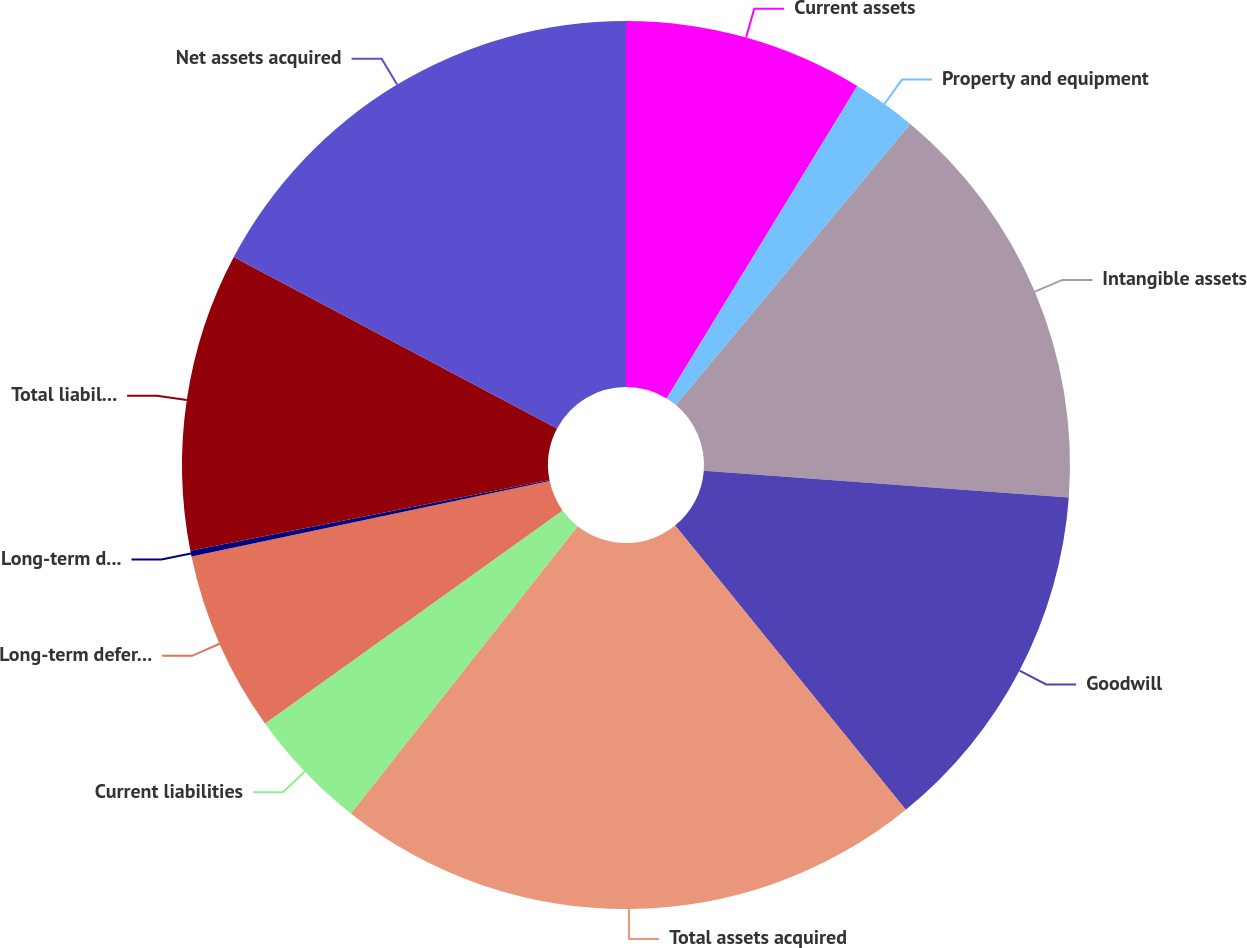Convert chart. <chart><loc_0><loc_0><loc_500><loc_500><pie_chart><fcel>Current assets<fcel>Property and equipment<fcel>Intangible assets<fcel>Goodwill<fcel>Total assets acquired<fcel>Current liabilities<fcel>Long-term deferred income<fcel>Long-term debt<fcel>Total liabilities assumed<fcel>Net assets acquired<nl><fcel>8.72%<fcel>2.34%<fcel>15.11%<fcel>12.98%<fcel>21.49%<fcel>4.47%<fcel>6.59%<fcel>0.21%<fcel>10.85%<fcel>17.24%<nl></chart> 